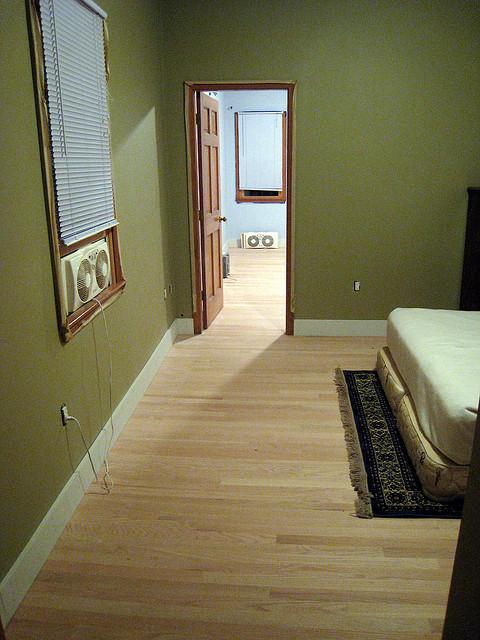What room is this?
Short answer required. Bedroom. Is the bed made?
Concise answer only. Yes. What is the white thing in the window under the blind?
Answer briefly. Fan. What color is the wall?
Concise answer only. Green. 